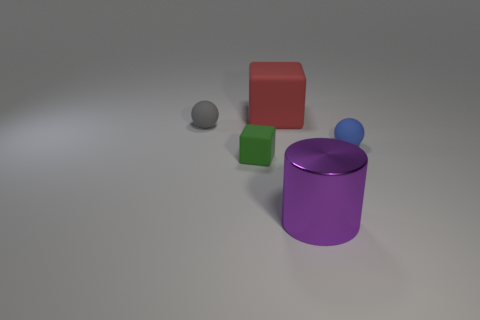Subtract all brown cylinders. Subtract all blue spheres. How many cylinders are left? 1 Add 4 small blue things. How many objects exist? 9 Subtract all blocks. How many objects are left? 3 Subtract 0 green spheres. How many objects are left? 5 Subtract all big purple cylinders. Subtract all big purple shiny things. How many objects are left? 3 Add 1 large purple shiny things. How many large purple shiny things are left? 2 Add 5 green matte cubes. How many green matte cubes exist? 6 